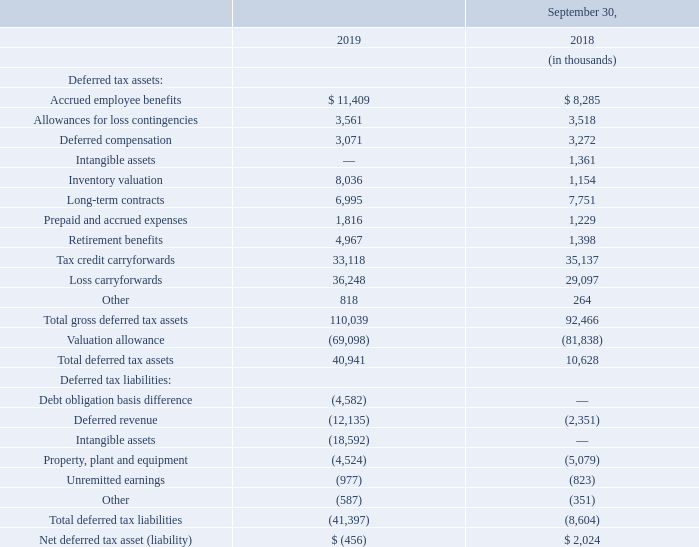Significant components of our deferred tax assets and liabilities are as follows:
The deferred tax assets and liabilities for fiscal 2019 and 2018 include amounts related to various acquisitions. The total change in deferred tax assets and liabilities in fiscal 2019 includes changes that are recorded to other comprehensive income (loss), retained earnings and goodwill.
We calculate deferred tax assets and liabilities based on differences between financial reporting and tax bases of assets and liabilities and measure them using the enacted tax rates and laws that we expect will be in effect when the differences reverse.
How are the deferred tax assets and liabilities calculated? Based on differences between financial reporting and tax bases of assets and liabilities and measure them using the enacted tax rates and laws that we expect will be in effect when the differences reverse. What does the total change in deferred tax assets and liabilities in 2019 include? Changes that are recorded to other comprehensive income (loss), retained earnings and goodwill. What are the items under deferred tax liabilities? Debt obligation basis difference, deferred revenue, intangible assets, property, plant and equipment, unremitted earnings, other. How many items are there under deferred tax liabilities? Debt obligation basis difference##Deferred revenue##Intangible assets##Property, plant and equipment##Unremitted earnings##Other
Answer: 6. What is the change in the amount of prepaid and accrued expenses from 2018 to 2019?
Answer scale should be: thousand. 1,816-1,229
Answer: 587. What is the percentage change in the amount of prepaid and accrued expenses from 2018 to 2019?
Answer scale should be: percent. (1,816-1,229)/1,229
Answer: 47.76. 